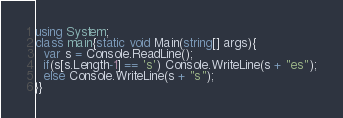<code> <loc_0><loc_0><loc_500><loc_500><_C#_>using System;
class main{static void Main(string[] args){
  var s = Console.ReadLine();
  if(s[s.Length-1] == 's') Console.WriteLine(s + "es");
  else Console.WriteLine(s + "s");
}}</code> 